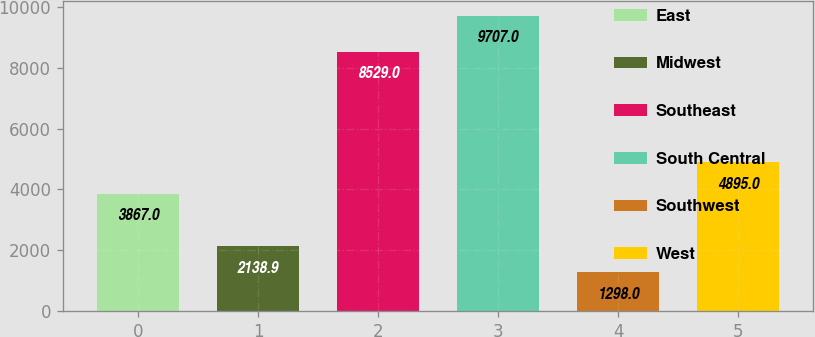Convert chart. <chart><loc_0><loc_0><loc_500><loc_500><bar_chart><fcel>East<fcel>Midwest<fcel>Southeast<fcel>South Central<fcel>Southwest<fcel>West<nl><fcel>3867<fcel>2138.9<fcel>8529<fcel>9707<fcel>1298<fcel>4895<nl></chart> 